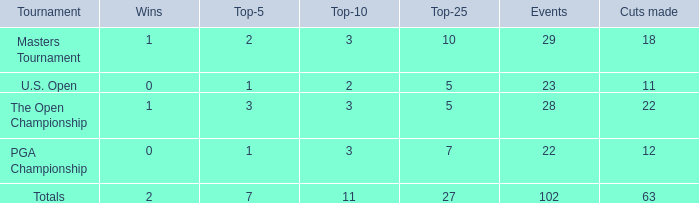How many cuts achieved for an athlete with 2 triumphs and less than 7 top 5s? None. 